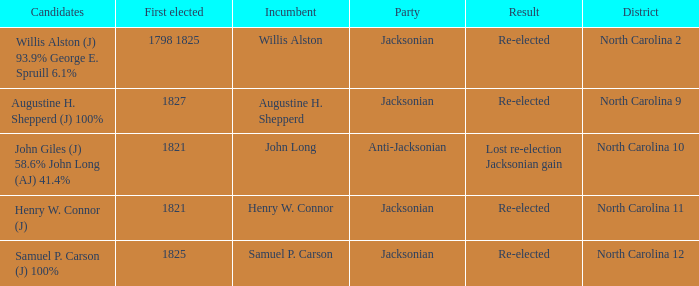Name the result for  augustine h. shepperd (j) 100% Re-elected. 